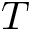Convert formula to latex. <formula><loc_0><loc_0><loc_500><loc_500>T</formula> 